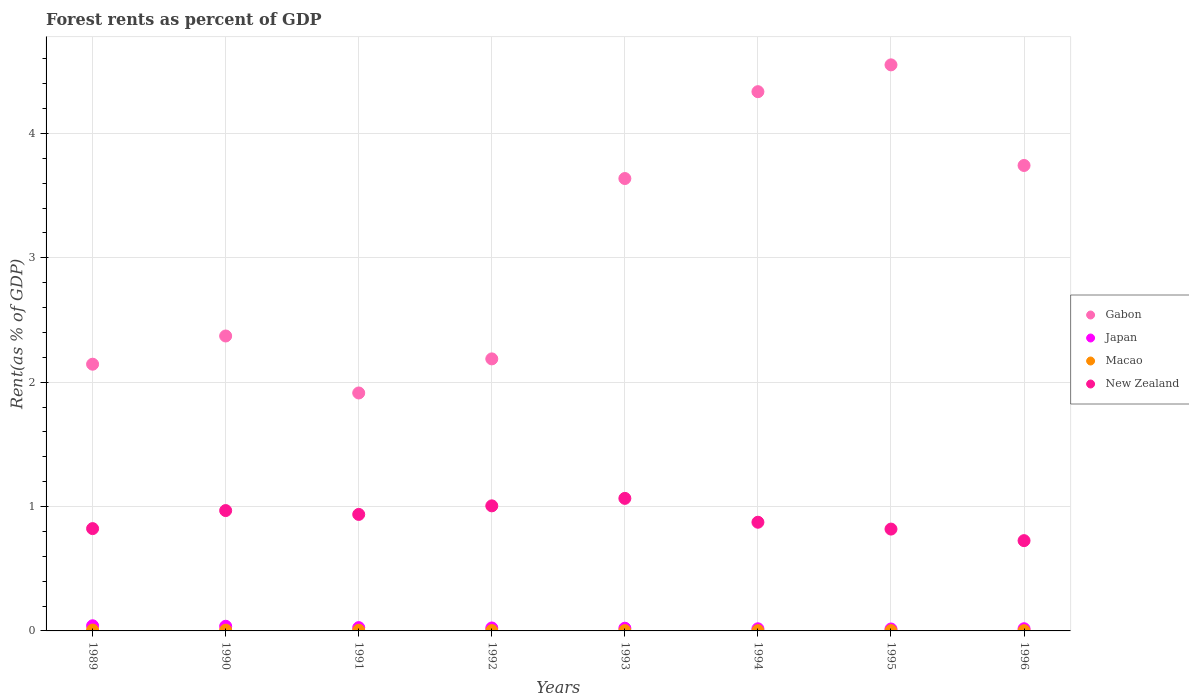What is the forest rent in Macao in 1991?
Provide a short and direct response. 0.01. Across all years, what is the maximum forest rent in Japan?
Keep it short and to the point. 0.04. Across all years, what is the minimum forest rent in Macao?
Your answer should be compact. 0. What is the total forest rent in New Zealand in the graph?
Provide a short and direct response. 7.22. What is the difference between the forest rent in Japan in 1991 and that in 1994?
Your answer should be compact. 0.01. What is the difference between the forest rent in Gabon in 1991 and the forest rent in Japan in 1992?
Provide a short and direct response. 1.89. What is the average forest rent in Macao per year?
Your answer should be compact. 0. In the year 1996, what is the difference between the forest rent in New Zealand and forest rent in Japan?
Provide a succinct answer. 0.71. What is the ratio of the forest rent in Gabon in 1991 to that in 1995?
Give a very brief answer. 0.42. What is the difference between the highest and the second highest forest rent in Japan?
Give a very brief answer. 0. What is the difference between the highest and the lowest forest rent in Japan?
Offer a terse response. 0.03. In how many years, is the forest rent in Gabon greater than the average forest rent in Gabon taken over all years?
Keep it short and to the point. 4. Is the sum of the forest rent in Gabon in 1990 and 1993 greater than the maximum forest rent in New Zealand across all years?
Make the answer very short. Yes. Is the forest rent in Gabon strictly less than the forest rent in Macao over the years?
Keep it short and to the point. No. How many dotlines are there?
Your answer should be very brief. 4. Are the values on the major ticks of Y-axis written in scientific E-notation?
Offer a terse response. No. Does the graph contain grids?
Your response must be concise. Yes. How many legend labels are there?
Provide a succinct answer. 4. What is the title of the graph?
Offer a very short reply. Forest rents as percent of GDP. What is the label or title of the Y-axis?
Give a very brief answer. Rent(as % of GDP). What is the Rent(as % of GDP) of Gabon in 1989?
Offer a very short reply. 2.14. What is the Rent(as % of GDP) of Japan in 1989?
Keep it short and to the point. 0.04. What is the Rent(as % of GDP) in Macao in 1989?
Keep it short and to the point. 0.01. What is the Rent(as % of GDP) of New Zealand in 1989?
Offer a very short reply. 0.82. What is the Rent(as % of GDP) of Gabon in 1990?
Provide a succinct answer. 2.37. What is the Rent(as % of GDP) of Japan in 1990?
Your response must be concise. 0.04. What is the Rent(as % of GDP) in Macao in 1990?
Your response must be concise. 0.01. What is the Rent(as % of GDP) in New Zealand in 1990?
Your answer should be compact. 0.97. What is the Rent(as % of GDP) in Gabon in 1991?
Your answer should be compact. 1.91. What is the Rent(as % of GDP) in Japan in 1991?
Offer a very short reply. 0.03. What is the Rent(as % of GDP) in Macao in 1991?
Your response must be concise. 0.01. What is the Rent(as % of GDP) of New Zealand in 1991?
Offer a terse response. 0.94. What is the Rent(as % of GDP) of Gabon in 1992?
Provide a succinct answer. 2.19. What is the Rent(as % of GDP) of Japan in 1992?
Your answer should be compact. 0.02. What is the Rent(as % of GDP) of Macao in 1992?
Offer a very short reply. 0. What is the Rent(as % of GDP) in New Zealand in 1992?
Your response must be concise. 1.01. What is the Rent(as % of GDP) in Gabon in 1993?
Keep it short and to the point. 3.64. What is the Rent(as % of GDP) of Japan in 1993?
Your answer should be compact. 0.02. What is the Rent(as % of GDP) in Macao in 1993?
Your response must be concise. 0. What is the Rent(as % of GDP) of New Zealand in 1993?
Provide a succinct answer. 1.07. What is the Rent(as % of GDP) of Gabon in 1994?
Keep it short and to the point. 4.34. What is the Rent(as % of GDP) in Japan in 1994?
Make the answer very short. 0.02. What is the Rent(as % of GDP) in Macao in 1994?
Ensure brevity in your answer.  0. What is the Rent(as % of GDP) of New Zealand in 1994?
Offer a very short reply. 0.87. What is the Rent(as % of GDP) of Gabon in 1995?
Provide a short and direct response. 4.55. What is the Rent(as % of GDP) in Japan in 1995?
Make the answer very short. 0.02. What is the Rent(as % of GDP) in Macao in 1995?
Give a very brief answer. 0. What is the Rent(as % of GDP) of New Zealand in 1995?
Offer a very short reply. 0.82. What is the Rent(as % of GDP) of Gabon in 1996?
Give a very brief answer. 3.74. What is the Rent(as % of GDP) of Japan in 1996?
Offer a very short reply. 0.02. What is the Rent(as % of GDP) of Macao in 1996?
Provide a short and direct response. 0. What is the Rent(as % of GDP) in New Zealand in 1996?
Offer a very short reply. 0.73. Across all years, what is the maximum Rent(as % of GDP) in Gabon?
Offer a very short reply. 4.55. Across all years, what is the maximum Rent(as % of GDP) in Japan?
Provide a succinct answer. 0.04. Across all years, what is the maximum Rent(as % of GDP) in Macao?
Your response must be concise. 0.01. Across all years, what is the maximum Rent(as % of GDP) in New Zealand?
Give a very brief answer. 1.07. Across all years, what is the minimum Rent(as % of GDP) of Gabon?
Provide a succinct answer. 1.91. Across all years, what is the minimum Rent(as % of GDP) of Japan?
Give a very brief answer. 0.02. Across all years, what is the minimum Rent(as % of GDP) in Macao?
Ensure brevity in your answer.  0. Across all years, what is the minimum Rent(as % of GDP) in New Zealand?
Make the answer very short. 0.73. What is the total Rent(as % of GDP) in Gabon in the graph?
Your answer should be compact. 24.89. What is the total Rent(as % of GDP) of Japan in the graph?
Ensure brevity in your answer.  0.2. What is the total Rent(as % of GDP) of Macao in the graph?
Give a very brief answer. 0.03. What is the total Rent(as % of GDP) in New Zealand in the graph?
Provide a succinct answer. 7.22. What is the difference between the Rent(as % of GDP) of Gabon in 1989 and that in 1990?
Your answer should be compact. -0.23. What is the difference between the Rent(as % of GDP) in Japan in 1989 and that in 1990?
Give a very brief answer. 0. What is the difference between the Rent(as % of GDP) of New Zealand in 1989 and that in 1990?
Offer a terse response. -0.15. What is the difference between the Rent(as % of GDP) of Gabon in 1989 and that in 1991?
Make the answer very short. 0.23. What is the difference between the Rent(as % of GDP) of Japan in 1989 and that in 1991?
Your answer should be compact. 0.01. What is the difference between the Rent(as % of GDP) in Macao in 1989 and that in 1991?
Give a very brief answer. 0. What is the difference between the Rent(as % of GDP) of New Zealand in 1989 and that in 1991?
Give a very brief answer. -0.11. What is the difference between the Rent(as % of GDP) of Gabon in 1989 and that in 1992?
Your response must be concise. -0.04. What is the difference between the Rent(as % of GDP) of Japan in 1989 and that in 1992?
Your response must be concise. 0.02. What is the difference between the Rent(as % of GDP) in Macao in 1989 and that in 1992?
Make the answer very short. 0. What is the difference between the Rent(as % of GDP) in New Zealand in 1989 and that in 1992?
Keep it short and to the point. -0.18. What is the difference between the Rent(as % of GDP) of Gabon in 1989 and that in 1993?
Provide a short and direct response. -1.49. What is the difference between the Rent(as % of GDP) of Japan in 1989 and that in 1993?
Offer a very short reply. 0.02. What is the difference between the Rent(as % of GDP) of Macao in 1989 and that in 1993?
Your response must be concise. 0. What is the difference between the Rent(as % of GDP) of New Zealand in 1989 and that in 1993?
Make the answer very short. -0.24. What is the difference between the Rent(as % of GDP) of Gabon in 1989 and that in 1994?
Provide a short and direct response. -2.19. What is the difference between the Rent(as % of GDP) in Japan in 1989 and that in 1994?
Your answer should be compact. 0.02. What is the difference between the Rent(as % of GDP) of Macao in 1989 and that in 1994?
Give a very brief answer. 0. What is the difference between the Rent(as % of GDP) of New Zealand in 1989 and that in 1994?
Your response must be concise. -0.05. What is the difference between the Rent(as % of GDP) of Gabon in 1989 and that in 1995?
Ensure brevity in your answer.  -2.41. What is the difference between the Rent(as % of GDP) of Japan in 1989 and that in 1995?
Give a very brief answer. 0.03. What is the difference between the Rent(as % of GDP) of Macao in 1989 and that in 1995?
Make the answer very short. 0. What is the difference between the Rent(as % of GDP) in New Zealand in 1989 and that in 1995?
Your answer should be compact. 0. What is the difference between the Rent(as % of GDP) in Gabon in 1989 and that in 1996?
Your answer should be compact. -1.6. What is the difference between the Rent(as % of GDP) in Japan in 1989 and that in 1996?
Make the answer very short. 0.02. What is the difference between the Rent(as % of GDP) in Macao in 1989 and that in 1996?
Provide a short and direct response. 0.01. What is the difference between the Rent(as % of GDP) of New Zealand in 1989 and that in 1996?
Provide a short and direct response. 0.1. What is the difference between the Rent(as % of GDP) in Gabon in 1990 and that in 1991?
Offer a very short reply. 0.46. What is the difference between the Rent(as % of GDP) of Japan in 1990 and that in 1991?
Provide a short and direct response. 0.01. What is the difference between the Rent(as % of GDP) in Macao in 1990 and that in 1991?
Your answer should be very brief. 0. What is the difference between the Rent(as % of GDP) in New Zealand in 1990 and that in 1991?
Your answer should be very brief. 0.03. What is the difference between the Rent(as % of GDP) in Gabon in 1990 and that in 1992?
Offer a terse response. 0.18. What is the difference between the Rent(as % of GDP) in Japan in 1990 and that in 1992?
Make the answer very short. 0.01. What is the difference between the Rent(as % of GDP) in Macao in 1990 and that in 1992?
Your answer should be compact. 0. What is the difference between the Rent(as % of GDP) of New Zealand in 1990 and that in 1992?
Provide a short and direct response. -0.04. What is the difference between the Rent(as % of GDP) of Gabon in 1990 and that in 1993?
Your answer should be compact. -1.27. What is the difference between the Rent(as % of GDP) in Japan in 1990 and that in 1993?
Give a very brief answer. 0.02. What is the difference between the Rent(as % of GDP) of Macao in 1990 and that in 1993?
Provide a succinct answer. 0. What is the difference between the Rent(as % of GDP) of New Zealand in 1990 and that in 1993?
Offer a very short reply. -0.1. What is the difference between the Rent(as % of GDP) of Gabon in 1990 and that in 1994?
Keep it short and to the point. -1.96. What is the difference between the Rent(as % of GDP) of Japan in 1990 and that in 1994?
Make the answer very short. 0.02. What is the difference between the Rent(as % of GDP) of Macao in 1990 and that in 1994?
Offer a very short reply. 0. What is the difference between the Rent(as % of GDP) in New Zealand in 1990 and that in 1994?
Your response must be concise. 0.09. What is the difference between the Rent(as % of GDP) in Gabon in 1990 and that in 1995?
Your response must be concise. -2.18. What is the difference between the Rent(as % of GDP) of Japan in 1990 and that in 1995?
Offer a terse response. 0.02. What is the difference between the Rent(as % of GDP) in Macao in 1990 and that in 1995?
Keep it short and to the point. 0. What is the difference between the Rent(as % of GDP) of New Zealand in 1990 and that in 1995?
Your answer should be very brief. 0.15. What is the difference between the Rent(as % of GDP) of Gabon in 1990 and that in 1996?
Give a very brief answer. -1.37. What is the difference between the Rent(as % of GDP) of Japan in 1990 and that in 1996?
Your answer should be compact. 0.02. What is the difference between the Rent(as % of GDP) in Macao in 1990 and that in 1996?
Offer a terse response. 0. What is the difference between the Rent(as % of GDP) of New Zealand in 1990 and that in 1996?
Give a very brief answer. 0.24. What is the difference between the Rent(as % of GDP) in Gabon in 1991 and that in 1992?
Make the answer very short. -0.27. What is the difference between the Rent(as % of GDP) in Japan in 1991 and that in 1992?
Your answer should be very brief. 0. What is the difference between the Rent(as % of GDP) of Macao in 1991 and that in 1992?
Offer a terse response. 0. What is the difference between the Rent(as % of GDP) of New Zealand in 1991 and that in 1992?
Your response must be concise. -0.07. What is the difference between the Rent(as % of GDP) in Gabon in 1991 and that in 1993?
Offer a very short reply. -1.72. What is the difference between the Rent(as % of GDP) of Japan in 1991 and that in 1993?
Ensure brevity in your answer.  0. What is the difference between the Rent(as % of GDP) in Macao in 1991 and that in 1993?
Make the answer very short. 0. What is the difference between the Rent(as % of GDP) of New Zealand in 1991 and that in 1993?
Ensure brevity in your answer.  -0.13. What is the difference between the Rent(as % of GDP) of Gabon in 1991 and that in 1994?
Provide a short and direct response. -2.42. What is the difference between the Rent(as % of GDP) of Japan in 1991 and that in 1994?
Ensure brevity in your answer.  0.01. What is the difference between the Rent(as % of GDP) in Macao in 1991 and that in 1994?
Your answer should be very brief. 0. What is the difference between the Rent(as % of GDP) of New Zealand in 1991 and that in 1994?
Your answer should be very brief. 0.06. What is the difference between the Rent(as % of GDP) in Gabon in 1991 and that in 1995?
Offer a terse response. -2.64. What is the difference between the Rent(as % of GDP) in Japan in 1991 and that in 1995?
Provide a short and direct response. 0.01. What is the difference between the Rent(as % of GDP) of Macao in 1991 and that in 1995?
Provide a short and direct response. 0. What is the difference between the Rent(as % of GDP) of New Zealand in 1991 and that in 1995?
Offer a terse response. 0.12. What is the difference between the Rent(as % of GDP) of Gabon in 1991 and that in 1996?
Your answer should be very brief. -1.83. What is the difference between the Rent(as % of GDP) in Japan in 1991 and that in 1996?
Keep it short and to the point. 0.01. What is the difference between the Rent(as % of GDP) in Macao in 1991 and that in 1996?
Offer a very short reply. 0. What is the difference between the Rent(as % of GDP) in New Zealand in 1991 and that in 1996?
Your answer should be very brief. 0.21. What is the difference between the Rent(as % of GDP) in Gabon in 1992 and that in 1993?
Offer a very short reply. -1.45. What is the difference between the Rent(as % of GDP) of Japan in 1992 and that in 1993?
Keep it short and to the point. 0. What is the difference between the Rent(as % of GDP) in Macao in 1992 and that in 1993?
Provide a short and direct response. 0. What is the difference between the Rent(as % of GDP) of New Zealand in 1992 and that in 1993?
Provide a short and direct response. -0.06. What is the difference between the Rent(as % of GDP) of Gabon in 1992 and that in 1994?
Offer a very short reply. -2.15. What is the difference between the Rent(as % of GDP) of Japan in 1992 and that in 1994?
Offer a terse response. 0.01. What is the difference between the Rent(as % of GDP) in Macao in 1992 and that in 1994?
Your answer should be very brief. 0. What is the difference between the Rent(as % of GDP) of New Zealand in 1992 and that in 1994?
Provide a succinct answer. 0.13. What is the difference between the Rent(as % of GDP) in Gabon in 1992 and that in 1995?
Offer a terse response. -2.36. What is the difference between the Rent(as % of GDP) in Japan in 1992 and that in 1995?
Your answer should be compact. 0.01. What is the difference between the Rent(as % of GDP) of Macao in 1992 and that in 1995?
Your response must be concise. 0. What is the difference between the Rent(as % of GDP) in New Zealand in 1992 and that in 1995?
Your answer should be compact. 0.19. What is the difference between the Rent(as % of GDP) in Gabon in 1992 and that in 1996?
Your response must be concise. -1.56. What is the difference between the Rent(as % of GDP) in Japan in 1992 and that in 1996?
Offer a terse response. 0.01. What is the difference between the Rent(as % of GDP) of New Zealand in 1992 and that in 1996?
Keep it short and to the point. 0.28. What is the difference between the Rent(as % of GDP) in Gabon in 1993 and that in 1994?
Provide a short and direct response. -0.7. What is the difference between the Rent(as % of GDP) of Japan in 1993 and that in 1994?
Provide a short and direct response. 0. What is the difference between the Rent(as % of GDP) in Macao in 1993 and that in 1994?
Offer a very short reply. -0. What is the difference between the Rent(as % of GDP) in New Zealand in 1993 and that in 1994?
Give a very brief answer. 0.19. What is the difference between the Rent(as % of GDP) in Gabon in 1993 and that in 1995?
Your answer should be compact. -0.91. What is the difference between the Rent(as % of GDP) in Japan in 1993 and that in 1995?
Make the answer very short. 0.01. What is the difference between the Rent(as % of GDP) of Macao in 1993 and that in 1995?
Give a very brief answer. -0. What is the difference between the Rent(as % of GDP) in New Zealand in 1993 and that in 1995?
Provide a succinct answer. 0.25. What is the difference between the Rent(as % of GDP) in Gabon in 1993 and that in 1996?
Your answer should be very brief. -0.1. What is the difference between the Rent(as % of GDP) in Japan in 1993 and that in 1996?
Make the answer very short. 0. What is the difference between the Rent(as % of GDP) in New Zealand in 1993 and that in 1996?
Your response must be concise. 0.34. What is the difference between the Rent(as % of GDP) in Gabon in 1994 and that in 1995?
Provide a short and direct response. -0.22. What is the difference between the Rent(as % of GDP) of Japan in 1994 and that in 1995?
Your answer should be very brief. 0. What is the difference between the Rent(as % of GDP) of Macao in 1994 and that in 1995?
Your answer should be compact. -0. What is the difference between the Rent(as % of GDP) in New Zealand in 1994 and that in 1995?
Your answer should be very brief. 0.06. What is the difference between the Rent(as % of GDP) of Gabon in 1994 and that in 1996?
Provide a short and direct response. 0.59. What is the difference between the Rent(as % of GDP) in Japan in 1994 and that in 1996?
Your answer should be very brief. -0. What is the difference between the Rent(as % of GDP) of New Zealand in 1994 and that in 1996?
Ensure brevity in your answer.  0.15. What is the difference between the Rent(as % of GDP) of Gabon in 1995 and that in 1996?
Ensure brevity in your answer.  0.81. What is the difference between the Rent(as % of GDP) of Japan in 1995 and that in 1996?
Give a very brief answer. -0. What is the difference between the Rent(as % of GDP) of Macao in 1995 and that in 1996?
Your response must be concise. 0. What is the difference between the Rent(as % of GDP) in New Zealand in 1995 and that in 1996?
Your response must be concise. 0.09. What is the difference between the Rent(as % of GDP) in Gabon in 1989 and the Rent(as % of GDP) in Japan in 1990?
Your answer should be compact. 2.11. What is the difference between the Rent(as % of GDP) in Gabon in 1989 and the Rent(as % of GDP) in Macao in 1990?
Offer a very short reply. 2.14. What is the difference between the Rent(as % of GDP) in Gabon in 1989 and the Rent(as % of GDP) in New Zealand in 1990?
Your answer should be very brief. 1.18. What is the difference between the Rent(as % of GDP) in Japan in 1989 and the Rent(as % of GDP) in Macao in 1990?
Give a very brief answer. 0.04. What is the difference between the Rent(as % of GDP) in Japan in 1989 and the Rent(as % of GDP) in New Zealand in 1990?
Provide a short and direct response. -0.93. What is the difference between the Rent(as % of GDP) in Macao in 1989 and the Rent(as % of GDP) in New Zealand in 1990?
Provide a succinct answer. -0.96. What is the difference between the Rent(as % of GDP) in Gabon in 1989 and the Rent(as % of GDP) in Japan in 1991?
Provide a short and direct response. 2.12. What is the difference between the Rent(as % of GDP) in Gabon in 1989 and the Rent(as % of GDP) in Macao in 1991?
Give a very brief answer. 2.14. What is the difference between the Rent(as % of GDP) of Gabon in 1989 and the Rent(as % of GDP) of New Zealand in 1991?
Make the answer very short. 1.21. What is the difference between the Rent(as % of GDP) of Japan in 1989 and the Rent(as % of GDP) of Macao in 1991?
Provide a short and direct response. 0.04. What is the difference between the Rent(as % of GDP) of Japan in 1989 and the Rent(as % of GDP) of New Zealand in 1991?
Keep it short and to the point. -0.9. What is the difference between the Rent(as % of GDP) of Macao in 1989 and the Rent(as % of GDP) of New Zealand in 1991?
Your answer should be compact. -0.93. What is the difference between the Rent(as % of GDP) in Gabon in 1989 and the Rent(as % of GDP) in Japan in 1992?
Your answer should be very brief. 2.12. What is the difference between the Rent(as % of GDP) in Gabon in 1989 and the Rent(as % of GDP) in Macao in 1992?
Make the answer very short. 2.14. What is the difference between the Rent(as % of GDP) of Gabon in 1989 and the Rent(as % of GDP) of New Zealand in 1992?
Offer a terse response. 1.14. What is the difference between the Rent(as % of GDP) in Japan in 1989 and the Rent(as % of GDP) in Macao in 1992?
Your answer should be compact. 0.04. What is the difference between the Rent(as % of GDP) in Japan in 1989 and the Rent(as % of GDP) in New Zealand in 1992?
Your answer should be very brief. -0.96. What is the difference between the Rent(as % of GDP) in Macao in 1989 and the Rent(as % of GDP) in New Zealand in 1992?
Keep it short and to the point. -1. What is the difference between the Rent(as % of GDP) in Gabon in 1989 and the Rent(as % of GDP) in Japan in 1993?
Your answer should be very brief. 2.12. What is the difference between the Rent(as % of GDP) in Gabon in 1989 and the Rent(as % of GDP) in Macao in 1993?
Your response must be concise. 2.14. What is the difference between the Rent(as % of GDP) of Gabon in 1989 and the Rent(as % of GDP) of New Zealand in 1993?
Make the answer very short. 1.08. What is the difference between the Rent(as % of GDP) in Japan in 1989 and the Rent(as % of GDP) in Macao in 1993?
Give a very brief answer. 0.04. What is the difference between the Rent(as % of GDP) of Japan in 1989 and the Rent(as % of GDP) of New Zealand in 1993?
Your answer should be very brief. -1.02. What is the difference between the Rent(as % of GDP) of Macao in 1989 and the Rent(as % of GDP) of New Zealand in 1993?
Offer a very short reply. -1.06. What is the difference between the Rent(as % of GDP) of Gabon in 1989 and the Rent(as % of GDP) of Japan in 1994?
Ensure brevity in your answer.  2.13. What is the difference between the Rent(as % of GDP) in Gabon in 1989 and the Rent(as % of GDP) in Macao in 1994?
Keep it short and to the point. 2.14. What is the difference between the Rent(as % of GDP) of Gabon in 1989 and the Rent(as % of GDP) of New Zealand in 1994?
Keep it short and to the point. 1.27. What is the difference between the Rent(as % of GDP) of Japan in 1989 and the Rent(as % of GDP) of Macao in 1994?
Offer a very short reply. 0.04. What is the difference between the Rent(as % of GDP) in Japan in 1989 and the Rent(as % of GDP) in New Zealand in 1994?
Ensure brevity in your answer.  -0.83. What is the difference between the Rent(as % of GDP) in Macao in 1989 and the Rent(as % of GDP) in New Zealand in 1994?
Your answer should be compact. -0.87. What is the difference between the Rent(as % of GDP) of Gabon in 1989 and the Rent(as % of GDP) of Japan in 1995?
Your answer should be very brief. 2.13. What is the difference between the Rent(as % of GDP) in Gabon in 1989 and the Rent(as % of GDP) in Macao in 1995?
Keep it short and to the point. 2.14. What is the difference between the Rent(as % of GDP) in Gabon in 1989 and the Rent(as % of GDP) in New Zealand in 1995?
Provide a succinct answer. 1.33. What is the difference between the Rent(as % of GDP) of Japan in 1989 and the Rent(as % of GDP) of Macao in 1995?
Ensure brevity in your answer.  0.04. What is the difference between the Rent(as % of GDP) of Japan in 1989 and the Rent(as % of GDP) of New Zealand in 1995?
Offer a very short reply. -0.78. What is the difference between the Rent(as % of GDP) in Macao in 1989 and the Rent(as % of GDP) in New Zealand in 1995?
Make the answer very short. -0.81. What is the difference between the Rent(as % of GDP) in Gabon in 1989 and the Rent(as % of GDP) in Japan in 1996?
Your answer should be compact. 2.13. What is the difference between the Rent(as % of GDP) in Gabon in 1989 and the Rent(as % of GDP) in Macao in 1996?
Make the answer very short. 2.14. What is the difference between the Rent(as % of GDP) of Gabon in 1989 and the Rent(as % of GDP) of New Zealand in 1996?
Offer a terse response. 1.42. What is the difference between the Rent(as % of GDP) in Japan in 1989 and the Rent(as % of GDP) in Macao in 1996?
Your answer should be compact. 0.04. What is the difference between the Rent(as % of GDP) in Japan in 1989 and the Rent(as % of GDP) in New Zealand in 1996?
Keep it short and to the point. -0.68. What is the difference between the Rent(as % of GDP) in Macao in 1989 and the Rent(as % of GDP) in New Zealand in 1996?
Ensure brevity in your answer.  -0.72. What is the difference between the Rent(as % of GDP) of Gabon in 1990 and the Rent(as % of GDP) of Japan in 1991?
Keep it short and to the point. 2.35. What is the difference between the Rent(as % of GDP) in Gabon in 1990 and the Rent(as % of GDP) in Macao in 1991?
Provide a short and direct response. 2.37. What is the difference between the Rent(as % of GDP) of Gabon in 1990 and the Rent(as % of GDP) of New Zealand in 1991?
Ensure brevity in your answer.  1.43. What is the difference between the Rent(as % of GDP) in Japan in 1990 and the Rent(as % of GDP) in Macao in 1991?
Your answer should be compact. 0.03. What is the difference between the Rent(as % of GDP) of Japan in 1990 and the Rent(as % of GDP) of New Zealand in 1991?
Give a very brief answer. -0.9. What is the difference between the Rent(as % of GDP) in Macao in 1990 and the Rent(as % of GDP) in New Zealand in 1991?
Your answer should be very brief. -0.93. What is the difference between the Rent(as % of GDP) of Gabon in 1990 and the Rent(as % of GDP) of Japan in 1992?
Offer a very short reply. 2.35. What is the difference between the Rent(as % of GDP) in Gabon in 1990 and the Rent(as % of GDP) in Macao in 1992?
Keep it short and to the point. 2.37. What is the difference between the Rent(as % of GDP) of Gabon in 1990 and the Rent(as % of GDP) of New Zealand in 1992?
Offer a very short reply. 1.37. What is the difference between the Rent(as % of GDP) in Japan in 1990 and the Rent(as % of GDP) in Macao in 1992?
Offer a terse response. 0.03. What is the difference between the Rent(as % of GDP) of Japan in 1990 and the Rent(as % of GDP) of New Zealand in 1992?
Provide a short and direct response. -0.97. What is the difference between the Rent(as % of GDP) in Macao in 1990 and the Rent(as % of GDP) in New Zealand in 1992?
Provide a short and direct response. -1. What is the difference between the Rent(as % of GDP) of Gabon in 1990 and the Rent(as % of GDP) of Japan in 1993?
Provide a short and direct response. 2.35. What is the difference between the Rent(as % of GDP) of Gabon in 1990 and the Rent(as % of GDP) of Macao in 1993?
Your answer should be compact. 2.37. What is the difference between the Rent(as % of GDP) in Gabon in 1990 and the Rent(as % of GDP) in New Zealand in 1993?
Give a very brief answer. 1.31. What is the difference between the Rent(as % of GDP) of Japan in 1990 and the Rent(as % of GDP) of Macao in 1993?
Offer a very short reply. 0.04. What is the difference between the Rent(as % of GDP) in Japan in 1990 and the Rent(as % of GDP) in New Zealand in 1993?
Your response must be concise. -1.03. What is the difference between the Rent(as % of GDP) in Macao in 1990 and the Rent(as % of GDP) in New Zealand in 1993?
Offer a very short reply. -1.06. What is the difference between the Rent(as % of GDP) in Gabon in 1990 and the Rent(as % of GDP) in Japan in 1994?
Give a very brief answer. 2.35. What is the difference between the Rent(as % of GDP) in Gabon in 1990 and the Rent(as % of GDP) in Macao in 1994?
Provide a short and direct response. 2.37. What is the difference between the Rent(as % of GDP) of Gabon in 1990 and the Rent(as % of GDP) of New Zealand in 1994?
Make the answer very short. 1.5. What is the difference between the Rent(as % of GDP) in Japan in 1990 and the Rent(as % of GDP) in Macao in 1994?
Your answer should be very brief. 0.04. What is the difference between the Rent(as % of GDP) in Japan in 1990 and the Rent(as % of GDP) in New Zealand in 1994?
Offer a terse response. -0.84. What is the difference between the Rent(as % of GDP) in Macao in 1990 and the Rent(as % of GDP) in New Zealand in 1994?
Keep it short and to the point. -0.87. What is the difference between the Rent(as % of GDP) of Gabon in 1990 and the Rent(as % of GDP) of Japan in 1995?
Provide a short and direct response. 2.36. What is the difference between the Rent(as % of GDP) in Gabon in 1990 and the Rent(as % of GDP) in Macao in 1995?
Ensure brevity in your answer.  2.37. What is the difference between the Rent(as % of GDP) in Gabon in 1990 and the Rent(as % of GDP) in New Zealand in 1995?
Your response must be concise. 1.55. What is the difference between the Rent(as % of GDP) in Japan in 1990 and the Rent(as % of GDP) in Macao in 1995?
Make the answer very short. 0.04. What is the difference between the Rent(as % of GDP) of Japan in 1990 and the Rent(as % of GDP) of New Zealand in 1995?
Keep it short and to the point. -0.78. What is the difference between the Rent(as % of GDP) in Macao in 1990 and the Rent(as % of GDP) in New Zealand in 1995?
Offer a terse response. -0.81. What is the difference between the Rent(as % of GDP) in Gabon in 1990 and the Rent(as % of GDP) in Japan in 1996?
Your answer should be compact. 2.35. What is the difference between the Rent(as % of GDP) in Gabon in 1990 and the Rent(as % of GDP) in Macao in 1996?
Offer a terse response. 2.37. What is the difference between the Rent(as % of GDP) in Gabon in 1990 and the Rent(as % of GDP) in New Zealand in 1996?
Offer a very short reply. 1.65. What is the difference between the Rent(as % of GDP) of Japan in 1990 and the Rent(as % of GDP) of Macao in 1996?
Your answer should be very brief. 0.04. What is the difference between the Rent(as % of GDP) of Japan in 1990 and the Rent(as % of GDP) of New Zealand in 1996?
Offer a terse response. -0.69. What is the difference between the Rent(as % of GDP) of Macao in 1990 and the Rent(as % of GDP) of New Zealand in 1996?
Provide a short and direct response. -0.72. What is the difference between the Rent(as % of GDP) in Gabon in 1991 and the Rent(as % of GDP) in Japan in 1992?
Make the answer very short. 1.89. What is the difference between the Rent(as % of GDP) in Gabon in 1991 and the Rent(as % of GDP) in Macao in 1992?
Keep it short and to the point. 1.91. What is the difference between the Rent(as % of GDP) in Gabon in 1991 and the Rent(as % of GDP) in New Zealand in 1992?
Ensure brevity in your answer.  0.91. What is the difference between the Rent(as % of GDP) in Japan in 1991 and the Rent(as % of GDP) in Macao in 1992?
Offer a very short reply. 0.02. What is the difference between the Rent(as % of GDP) in Japan in 1991 and the Rent(as % of GDP) in New Zealand in 1992?
Your response must be concise. -0.98. What is the difference between the Rent(as % of GDP) in Macao in 1991 and the Rent(as % of GDP) in New Zealand in 1992?
Your response must be concise. -1. What is the difference between the Rent(as % of GDP) in Gabon in 1991 and the Rent(as % of GDP) in Japan in 1993?
Provide a short and direct response. 1.89. What is the difference between the Rent(as % of GDP) in Gabon in 1991 and the Rent(as % of GDP) in Macao in 1993?
Make the answer very short. 1.91. What is the difference between the Rent(as % of GDP) of Gabon in 1991 and the Rent(as % of GDP) of New Zealand in 1993?
Offer a very short reply. 0.85. What is the difference between the Rent(as % of GDP) in Japan in 1991 and the Rent(as % of GDP) in Macao in 1993?
Your response must be concise. 0.02. What is the difference between the Rent(as % of GDP) of Japan in 1991 and the Rent(as % of GDP) of New Zealand in 1993?
Ensure brevity in your answer.  -1.04. What is the difference between the Rent(as % of GDP) of Macao in 1991 and the Rent(as % of GDP) of New Zealand in 1993?
Offer a very short reply. -1.06. What is the difference between the Rent(as % of GDP) in Gabon in 1991 and the Rent(as % of GDP) in Japan in 1994?
Your answer should be very brief. 1.9. What is the difference between the Rent(as % of GDP) of Gabon in 1991 and the Rent(as % of GDP) of Macao in 1994?
Your answer should be compact. 1.91. What is the difference between the Rent(as % of GDP) in Gabon in 1991 and the Rent(as % of GDP) in New Zealand in 1994?
Provide a succinct answer. 1.04. What is the difference between the Rent(as % of GDP) of Japan in 1991 and the Rent(as % of GDP) of Macao in 1994?
Your answer should be compact. 0.02. What is the difference between the Rent(as % of GDP) in Japan in 1991 and the Rent(as % of GDP) in New Zealand in 1994?
Offer a terse response. -0.85. What is the difference between the Rent(as % of GDP) in Macao in 1991 and the Rent(as % of GDP) in New Zealand in 1994?
Ensure brevity in your answer.  -0.87. What is the difference between the Rent(as % of GDP) of Gabon in 1991 and the Rent(as % of GDP) of Japan in 1995?
Make the answer very short. 1.9. What is the difference between the Rent(as % of GDP) in Gabon in 1991 and the Rent(as % of GDP) in Macao in 1995?
Provide a succinct answer. 1.91. What is the difference between the Rent(as % of GDP) in Gabon in 1991 and the Rent(as % of GDP) in New Zealand in 1995?
Make the answer very short. 1.09. What is the difference between the Rent(as % of GDP) of Japan in 1991 and the Rent(as % of GDP) of Macao in 1995?
Keep it short and to the point. 0.02. What is the difference between the Rent(as % of GDP) of Japan in 1991 and the Rent(as % of GDP) of New Zealand in 1995?
Provide a short and direct response. -0.79. What is the difference between the Rent(as % of GDP) of Macao in 1991 and the Rent(as % of GDP) of New Zealand in 1995?
Make the answer very short. -0.81. What is the difference between the Rent(as % of GDP) of Gabon in 1991 and the Rent(as % of GDP) of Japan in 1996?
Provide a short and direct response. 1.9. What is the difference between the Rent(as % of GDP) of Gabon in 1991 and the Rent(as % of GDP) of Macao in 1996?
Your response must be concise. 1.91. What is the difference between the Rent(as % of GDP) of Gabon in 1991 and the Rent(as % of GDP) of New Zealand in 1996?
Your response must be concise. 1.19. What is the difference between the Rent(as % of GDP) in Japan in 1991 and the Rent(as % of GDP) in Macao in 1996?
Your answer should be compact. 0.02. What is the difference between the Rent(as % of GDP) in Japan in 1991 and the Rent(as % of GDP) in New Zealand in 1996?
Make the answer very short. -0.7. What is the difference between the Rent(as % of GDP) of Macao in 1991 and the Rent(as % of GDP) of New Zealand in 1996?
Your answer should be compact. -0.72. What is the difference between the Rent(as % of GDP) of Gabon in 1992 and the Rent(as % of GDP) of Japan in 1993?
Your response must be concise. 2.17. What is the difference between the Rent(as % of GDP) in Gabon in 1992 and the Rent(as % of GDP) in Macao in 1993?
Provide a short and direct response. 2.19. What is the difference between the Rent(as % of GDP) in Gabon in 1992 and the Rent(as % of GDP) in New Zealand in 1993?
Keep it short and to the point. 1.12. What is the difference between the Rent(as % of GDP) in Japan in 1992 and the Rent(as % of GDP) in Macao in 1993?
Your response must be concise. 0.02. What is the difference between the Rent(as % of GDP) of Japan in 1992 and the Rent(as % of GDP) of New Zealand in 1993?
Keep it short and to the point. -1.04. What is the difference between the Rent(as % of GDP) of Macao in 1992 and the Rent(as % of GDP) of New Zealand in 1993?
Keep it short and to the point. -1.06. What is the difference between the Rent(as % of GDP) in Gabon in 1992 and the Rent(as % of GDP) in Japan in 1994?
Give a very brief answer. 2.17. What is the difference between the Rent(as % of GDP) in Gabon in 1992 and the Rent(as % of GDP) in Macao in 1994?
Ensure brevity in your answer.  2.19. What is the difference between the Rent(as % of GDP) of Gabon in 1992 and the Rent(as % of GDP) of New Zealand in 1994?
Offer a terse response. 1.31. What is the difference between the Rent(as % of GDP) in Japan in 1992 and the Rent(as % of GDP) in Macao in 1994?
Your answer should be compact. 0.02. What is the difference between the Rent(as % of GDP) in Japan in 1992 and the Rent(as % of GDP) in New Zealand in 1994?
Keep it short and to the point. -0.85. What is the difference between the Rent(as % of GDP) of Macao in 1992 and the Rent(as % of GDP) of New Zealand in 1994?
Ensure brevity in your answer.  -0.87. What is the difference between the Rent(as % of GDP) in Gabon in 1992 and the Rent(as % of GDP) in Japan in 1995?
Keep it short and to the point. 2.17. What is the difference between the Rent(as % of GDP) in Gabon in 1992 and the Rent(as % of GDP) in Macao in 1995?
Your response must be concise. 2.19. What is the difference between the Rent(as % of GDP) of Gabon in 1992 and the Rent(as % of GDP) of New Zealand in 1995?
Ensure brevity in your answer.  1.37. What is the difference between the Rent(as % of GDP) of Japan in 1992 and the Rent(as % of GDP) of Macao in 1995?
Ensure brevity in your answer.  0.02. What is the difference between the Rent(as % of GDP) in Japan in 1992 and the Rent(as % of GDP) in New Zealand in 1995?
Offer a very short reply. -0.8. What is the difference between the Rent(as % of GDP) in Macao in 1992 and the Rent(as % of GDP) in New Zealand in 1995?
Your answer should be very brief. -0.82. What is the difference between the Rent(as % of GDP) of Gabon in 1992 and the Rent(as % of GDP) of Japan in 1996?
Your answer should be very brief. 2.17. What is the difference between the Rent(as % of GDP) of Gabon in 1992 and the Rent(as % of GDP) of Macao in 1996?
Make the answer very short. 2.19. What is the difference between the Rent(as % of GDP) in Gabon in 1992 and the Rent(as % of GDP) in New Zealand in 1996?
Give a very brief answer. 1.46. What is the difference between the Rent(as % of GDP) in Japan in 1992 and the Rent(as % of GDP) in Macao in 1996?
Give a very brief answer. 0.02. What is the difference between the Rent(as % of GDP) in Japan in 1992 and the Rent(as % of GDP) in New Zealand in 1996?
Provide a succinct answer. -0.7. What is the difference between the Rent(as % of GDP) of Macao in 1992 and the Rent(as % of GDP) of New Zealand in 1996?
Your answer should be compact. -0.72. What is the difference between the Rent(as % of GDP) of Gabon in 1993 and the Rent(as % of GDP) of Japan in 1994?
Your answer should be compact. 3.62. What is the difference between the Rent(as % of GDP) of Gabon in 1993 and the Rent(as % of GDP) of Macao in 1994?
Make the answer very short. 3.64. What is the difference between the Rent(as % of GDP) of Gabon in 1993 and the Rent(as % of GDP) of New Zealand in 1994?
Give a very brief answer. 2.76. What is the difference between the Rent(as % of GDP) of Japan in 1993 and the Rent(as % of GDP) of Macao in 1994?
Your response must be concise. 0.02. What is the difference between the Rent(as % of GDP) in Japan in 1993 and the Rent(as % of GDP) in New Zealand in 1994?
Make the answer very short. -0.85. What is the difference between the Rent(as % of GDP) of Macao in 1993 and the Rent(as % of GDP) of New Zealand in 1994?
Your answer should be compact. -0.87. What is the difference between the Rent(as % of GDP) in Gabon in 1993 and the Rent(as % of GDP) in Japan in 1995?
Your answer should be compact. 3.62. What is the difference between the Rent(as % of GDP) in Gabon in 1993 and the Rent(as % of GDP) in Macao in 1995?
Keep it short and to the point. 3.64. What is the difference between the Rent(as % of GDP) of Gabon in 1993 and the Rent(as % of GDP) of New Zealand in 1995?
Give a very brief answer. 2.82. What is the difference between the Rent(as % of GDP) in Japan in 1993 and the Rent(as % of GDP) in Macao in 1995?
Ensure brevity in your answer.  0.02. What is the difference between the Rent(as % of GDP) of Japan in 1993 and the Rent(as % of GDP) of New Zealand in 1995?
Your answer should be very brief. -0.8. What is the difference between the Rent(as % of GDP) in Macao in 1993 and the Rent(as % of GDP) in New Zealand in 1995?
Give a very brief answer. -0.82. What is the difference between the Rent(as % of GDP) in Gabon in 1993 and the Rent(as % of GDP) in Japan in 1996?
Give a very brief answer. 3.62. What is the difference between the Rent(as % of GDP) of Gabon in 1993 and the Rent(as % of GDP) of Macao in 1996?
Give a very brief answer. 3.64. What is the difference between the Rent(as % of GDP) of Gabon in 1993 and the Rent(as % of GDP) of New Zealand in 1996?
Provide a succinct answer. 2.91. What is the difference between the Rent(as % of GDP) of Japan in 1993 and the Rent(as % of GDP) of Macao in 1996?
Make the answer very short. 0.02. What is the difference between the Rent(as % of GDP) of Japan in 1993 and the Rent(as % of GDP) of New Zealand in 1996?
Provide a short and direct response. -0.7. What is the difference between the Rent(as % of GDP) in Macao in 1993 and the Rent(as % of GDP) in New Zealand in 1996?
Offer a very short reply. -0.72. What is the difference between the Rent(as % of GDP) in Gabon in 1994 and the Rent(as % of GDP) in Japan in 1995?
Make the answer very short. 4.32. What is the difference between the Rent(as % of GDP) in Gabon in 1994 and the Rent(as % of GDP) in Macao in 1995?
Your answer should be compact. 4.33. What is the difference between the Rent(as % of GDP) of Gabon in 1994 and the Rent(as % of GDP) of New Zealand in 1995?
Your answer should be very brief. 3.52. What is the difference between the Rent(as % of GDP) of Japan in 1994 and the Rent(as % of GDP) of Macao in 1995?
Your answer should be compact. 0.01. What is the difference between the Rent(as % of GDP) in Japan in 1994 and the Rent(as % of GDP) in New Zealand in 1995?
Offer a very short reply. -0.8. What is the difference between the Rent(as % of GDP) in Macao in 1994 and the Rent(as % of GDP) in New Zealand in 1995?
Ensure brevity in your answer.  -0.82. What is the difference between the Rent(as % of GDP) in Gabon in 1994 and the Rent(as % of GDP) in Japan in 1996?
Provide a succinct answer. 4.32. What is the difference between the Rent(as % of GDP) in Gabon in 1994 and the Rent(as % of GDP) in Macao in 1996?
Make the answer very short. 4.33. What is the difference between the Rent(as % of GDP) in Gabon in 1994 and the Rent(as % of GDP) in New Zealand in 1996?
Make the answer very short. 3.61. What is the difference between the Rent(as % of GDP) in Japan in 1994 and the Rent(as % of GDP) in Macao in 1996?
Make the answer very short. 0.02. What is the difference between the Rent(as % of GDP) of Japan in 1994 and the Rent(as % of GDP) of New Zealand in 1996?
Your answer should be compact. -0.71. What is the difference between the Rent(as % of GDP) of Macao in 1994 and the Rent(as % of GDP) of New Zealand in 1996?
Your response must be concise. -0.72. What is the difference between the Rent(as % of GDP) of Gabon in 1995 and the Rent(as % of GDP) of Japan in 1996?
Your answer should be compact. 4.53. What is the difference between the Rent(as % of GDP) of Gabon in 1995 and the Rent(as % of GDP) of Macao in 1996?
Your answer should be very brief. 4.55. What is the difference between the Rent(as % of GDP) of Gabon in 1995 and the Rent(as % of GDP) of New Zealand in 1996?
Your answer should be compact. 3.83. What is the difference between the Rent(as % of GDP) of Japan in 1995 and the Rent(as % of GDP) of Macao in 1996?
Your response must be concise. 0.01. What is the difference between the Rent(as % of GDP) of Japan in 1995 and the Rent(as % of GDP) of New Zealand in 1996?
Give a very brief answer. -0.71. What is the difference between the Rent(as % of GDP) of Macao in 1995 and the Rent(as % of GDP) of New Zealand in 1996?
Keep it short and to the point. -0.72. What is the average Rent(as % of GDP) in Gabon per year?
Make the answer very short. 3.11. What is the average Rent(as % of GDP) in Japan per year?
Your response must be concise. 0.03. What is the average Rent(as % of GDP) in Macao per year?
Provide a succinct answer. 0. What is the average Rent(as % of GDP) in New Zealand per year?
Your response must be concise. 0.9. In the year 1989, what is the difference between the Rent(as % of GDP) in Gabon and Rent(as % of GDP) in Japan?
Ensure brevity in your answer.  2.1. In the year 1989, what is the difference between the Rent(as % of GDP) of Gabon and Rent(as % of GDP) of Macao?
Give a very brief answer. 2.14. In the year 1989, what is the difference between the Rent(as % of GDP) in Gabon and Rent(as % of GDP) in New Zealand?
Your answer should be compact. 1.32. In the year 1989, what is the difference between the Rent(as % of GDP) of Japan and Rent(as % of GDP) of Macao?
Provide a short and direct response. 0.03. In the year 1989, what is the difference between the Rent(as % of GDP) of Japan and Rent(as % of GDP) of New Zealand?
Keep it short and to the point. -0.78. In the year 1989, what is the difference between the Rent(as % of GDP) in Macao and Rent(as % of GDP) in New Zealand?
Provide a short and direct response. -0.82. In the year 1990, what is the difference between the Rent(as % of GDP) of Gabon and Rent(as % of GDP) of Japan?
Keep it short and to the point. 2.33. In the year 1990, what is the difference between the Rent(as % of GDP) in Gabon and Rent(as % of GDP) in Macao?
Keep it short and to the point. 2.37. In the year 1990, what is the difference between the Rent(as % of GDP) in Gabon and Rent(as % of GDP) in New Zealand?
Provide a short and direct response. 1.4. In the year 1990, what is the difference between the Rent(as % of GDP) in Japan and Rent(as % of GDP) in Macao?
Your answer should be very brief. 0.03. In the year 1990, what is the difference between the Rent(as % of GDP) in Japan and Rent(as % of GDP) in New Zealand?
Provide a short and direct response. -0.93. In the year 1990, what is the difference between the Rent(as % of GDP) in Macao and Rent(as % of GDP) in New Zealand?
Provide a short and direct response. -0.96. In the year 1991, what is the difference between the Rent(as % of GDP) in Gabon and Rent(as % of GDP) in Japan?
Offer a terse response. 1.89. In the year 1991, what is the difference between the Rent(as % of GDP) in Gabon and Rent(as % of GDP) in Macao?
Offer a very short reply. 1.91. In the year 1991, what is the difference between the Rent(as % of GDP) in Gabon and Rent(as % of GDP) in New Zealand?
Your answer should be very brief. 0.98. In the year 1991, what is the difference between the Rent(as % of GDP) of Japan and Rent(as % of GDP) of Macao?
Provide a succinct answer. 0.02. In the year 1991, what is the difference between the Rent(as % of GDP) of Japan and Rent(as % of GDP) of New Zealand?
Provide a succinct answer. -0.91. In the year 1991, what is the difference between the Rent(as % of GDP) of Macao and Rent(as % of GDP) of New Zealand?
Give a very brief answer. -0.93. In the year 1992, what is the difference between the Rent(as % of GDP) in Gabon and Rent(as % of GDP) in Japan?
Your response must be concise. 2.16. In the year 1992, what is the difference between the Rent(as % of GDP) of Gabon and Rent(as % of GDP) of Macao?
Ensure brevity in your answer.  2.18. In the year 1992, what is the difference between the Rent(as % of GDP) in Gabon and Rent(as % of GDP) in New Zealand?
Your response must be concise. 1.18. In the year 1992, what is the difference between the Rent(as % of GDP) in Japan and Rent(as % of GDP) in Macao?
Keep it short and to the point. 0.02. In the year 1992, what is the difference between the Rent(as % of GDP) of Japan and Rent(as % of GDP) of New Zealand?
Provide a short and direct response. -0.98. In the year 1992, what is the difference between the Rent(as % of GDP) in Macao and Rent(as % of GDP) in New Zealand?
Give a very brief answer. -1. In the year 1993, what is the difference between the Rent(as % of GDP) in Gabon and Rent(as % of GDP) in Japan?
Your response must be concise. 3.62. In the year 1993, what is the difference between the Rent(as % of GDP) in Gabon and Rent(as % of GDP) in Macao?
Make the answer very short. 3.64. In the year 1993, what is the difference between the Rent(as % of GDP) in Gabon and Rent(as % of GDP) in New Zealand?
Give a very brief answer. 2.57. In the year 1993, what is the difference between the Rent(as % of GDP) of Japan and Rent(as % of GDP) of Macao?
Ensure brevity in your answer.  0.02. In the year 1993, what is the difference between the Rent(as % of GDP) in Japan and Rent(as % of GDP) in New Zealand?
Make the answer very short. -1.04. In the year 1993, what is the difference between the Rent(as % of GDP) in Macao and Rent(as % of GDP) in New Zealand?
Your response must be concise. -1.06. In the year 1994, what is the difference between the Rent(as % of GDP) in Gabon and Rent(as % of GDP) in Japan?
Offer a very short reply. 4.32. In the year 1994, what is the difference between the Rent(as % of GDP) of Gabon and Rent(as % of GDP) of Macao?
Your answer should be very brief. 4.33. In the year 1994, what is the difference between the Rent(as % of GDP) in Gabon and Rent(as % of GDP) in New Zealand?
Offer a very short reply. 3.46. In the year 1994, what is the difference between the Rent(as % of GDP) of Japan and Rent(as % of GDP) of Macao?
Ensure brevity in your answer.  0.01. In the year 1994, what is the difference between the Rent(as % of GDP) of Japan and Rent(as % of GDP) of New Zealand?
Your answer should be compact. -0.86. In the year 1994, what is the difference between the Rent(as % of GDP) of Macao and Rent(as % of GDP) of New Zealand?
Give a very brief answer. -0.87. In the year 1995, what is the difference between the Rent(as % of GDP) of Gabon and Rent(as % of GDP) of Japan?
Your answer should be very brief. 4.54. In the year 1995, what is the difference between the Rent(as % of GDP) of Gabon and Rent(as % of GDP) of Macao?
Keep it short and to the point. 4.55. In the year 1995, what is the difference between the Rent(as % of GDP) of Gabon and Rent(as % of GDP) of New Zealand?
Make the answer very short. 3.73. In the year 1995, what is the difference between the Rent(as % of GDP) in Japan and Rent(as % of GDP) in Macao?
Your response must be concise. 0.01. In the year 1995, what is the difference between the Rent(as % of GDP) in Japan and Rent(as % of GDP) in New Zealand?
Offer a terse response. -0.8. In the year 1995, what is the difference between the Rent(as % of GDP) in Macao and Rent(as % of GDP) in New Zealand?
Provide a succinct answer. -0.82. In the year 1996, what is the difference between the Rent(as % of GDP) in Gabon and Rent(as % of GDP) in Japan?
Provide a succinct answer. 3.73. In the year 1996, what is the difference between the Rent(as % of GDP) in Gabon and Rent(as % of GDP) in Macao?
Your answer should be very brief. 3.74. In the year 1996, what is the difference between the Rent(as % of GDP) of Gabon and Rent(as % of GDP) of New Zealand?
Your answer should be compact. 3.02. In the year 1996, what is the difference between the Rent(as % of GDP) of Japan and Rent(as % of GDP) of Macao?
Your answer should be very brief. 0.02. In the year 1996, what is the difference between the Rent(as % of GDP) of Japan and Rent(as % of GDP) of New Zealand?
Keep it short and to the point. -0.71. In the year 1996, what is the difference between the Rent(as % of GDP) in Macao and Rent(as % of GDP) in New Zealand?
Make the answer very short. -0.72. What is the ratio of the Rent(as % of GDP) of Gabon in 1989 to that in 1990?
Keep it short and to the point. 0.9. What is the ratio of the Rent(as % of GDP) in Japan in 1989 to that in 1990?
Your answer should be very brief. 1.1. What is the ratio of the Rent(as % of GDP) of Macao in 1989 to that in 1990?
Ensure brevity in your answer.  1.17. What is the ratio of the Rent(as % of GDP) in New Zealand in 1989 to that in 1990?
Ensure brevity in your answer.  0.85. What is the ratio of the Rent(as % of GDP) of Gabon in 1989 to that in 1991?
Your response must be concise. 1.12. What is the ratio of the Rent(as % of GDP) in Japan in 1989 to that in 1991?
Keep it short and to the point. 1.56. What is the ratio of the Rent(as % of GDP) of Macao in 1989 to that in 1991?
Your answer should be very brief. 1.31. What is the ratio of the Rent(as % of GDP) of New Zealand in 1989 to that in 1991?
Your answer should be very brief. 0.88. What is the ratio of the Rent(as % of GDP) in Gabon in 1989 to that in 1992?
Provide a short and direct response. 0.98. What is the ratio of the Rent(as % of GDP) of Japan in 1989 to that in 1992?
Your answer should be compact. 1.75. What is the ratio of the Rent(as % of GDP) of Macao in 1989 to that in 1992?
Your answer should be very brief. 2.4. What is the ratio of the Rent(as % of GDP) in New Zealand in 1989 to that in 1992?
Your answer should be compact. 0.82. What is the ratio of the Rent(as % of GDP) of Gabon in 1989 to that in 1993?
Keep it short and to the point. 0.59. What is the ratio of the Rent(as % of GDP) of Japan in 1989 to that in 1993?
Your answer should be very brief. 1.9. What is the ratio of the Rent(as % of GDP) of Macao in 1989 to that in 1993?
Your answer should be compact. 3.32. What is the ratio of the Rent(as % of GDP) in New Zealand in 1989 to that in 1993?
Your answer should be very brief. 0.77. What is the ratio of the Rent(as % of GDP) of Gabon in 1989 to that in 1994?
Keep it short and to the point. 0.49. What is the ratio of the Rent(as % of GDP) of Japan in 1989 to that in 1994?
Your response must be concise. 2.41. What is the ratio of the Rent(as % of GDP) in Macao in 1989 to that in 1994?
Give a very brief answer. 3.31. What is the ratio of the Rent(as % of GDP) in New Zealand in 1989 to that in 1994?
Offer a very short reply. 0.94. What is the ratio of the Rent(as % of GDP) in Gabon in 1989 to that in 1995?
Your response must be concise. 0.47. What is the ratio of the Rent(as % of GDP) in Japan in 1989 to that in 1995?
Ensure brevity in your answer.  2.67. What is the ratio of the Rent(as % of GDP) in Macao in 1989 to that in 1995?
Give a very brief answer. 3.01. What is the ratio of the Rent(as % of GDP) in Gabon in 1989 to that in 1996?
Offer a terse response. 0.57. What is the ratio of the Rent(as % of GDP) of Japan in 1989 to that in 1996?
Your response must be concise. 2.36. What is the ratio of the Rent(as % of GDP) of Macao in 1989 to that in 1996?
Your answer should be very brief. 3.71. What is the ratio of the Rent(as % of GDP) of New Zealand in 1989 to that in 1996?
Your answer should be very brief. 1.13. What is the ratio of the Rent(as % of GDP) in Gabon in 1990 to that in 1991?
Keep it short and to the point. 1.24. What is the ratio of the Rent(as % of GDP) of Japan in 1990 to that in 1991?
Offer a very short reply. 1.41. What is the ratio of the Rent(as % of GDP) of Macao in 1990 to that in 1991?
Make the answer very short. 1.12. What is the ratio of the Rent(as % of GDP) in New Zealand in 1990 to that in 1991?
Ensure brevity in your answer.  1.03. What is the ratio of the Rent(as % of GDP) of Gabon in 1990 to that in 1992?
Keep it short and to the point. 1.08. What is the ratio of the Rent(as % of GDP) in Japan in 1990 to that in 1992?
Offer a terse response. 1.58. What is the ratio of the Rent(as % of GDP) in Macao in 1990 to that in 1992?
Make the answer very short. 2.06. What is the ratio of the Rent(as % of GDP) of New Zealand in 1990 to that in 1992?
Ensure brevity in your answer.  0.96. What is the ratio of the Rent(as % of GDP) in Gabon in 1990 to that in 1993?
Offer a terse response. 0.65. What is the ratio of the Rent(as % of GDP) of Japan in 1990 to that in 1993?
Your response must be concise. 1.72. What is the ratio of the Rent(as % of GDP) of Macao in 1990 to that in 1993?
Your answer should be compact. 2.85. What is the ratio of the Rent(as % of GDP) in New Zealand in 1990 to that in 1993?
Give a very brief answer. 0.91. What is the ratio of the Rent(as % of GDP) of Gabon in 1990 to that in 1994?
Your answer should be very brief. 0.55. What is the ratio of the Rent(as % of GDP) of Japan in 1990 to that in 1994?
Ensure brevity in your answer.  2.18. What is the ratio of the Rent(as % of GDP) in Macao in 1990 to that in 1994?
Your answer should be compact. 2.84. What is the ratio of the Rent(as % of GDP) of New Zealand in 1990 to that in 1994?
Provide a succinct answer. 1.11. What is the ratio of the Rent(as % of GDP) of Gabon in 1990 to that in 1995?
Offer a terse response. 0.52. What is the ratio of the Rent(as % of GDP) in Japan in 1990 to that in 1995?
Offer a very short reply. 2.42. What is the ratio of the Rent(as % of GDP) of Macao in 1990 to that in 1995?
Provide a succinct answer. 2.58. What is the ratio of the Rent(as % of GDP) of New Zealand in 1990 to that in 1995?
Keep it short and to the point. 1.18. What is the ratio of the Rent(as % of GDP) in Gabon in 1990 to that in 1996?
Your response must be concise. 0.63. What is the ratio of the Rent(as % of GDP) of Japan in 1990 to that in 1996?
Give a very brief answer. 2.13. What is the ratio of the Rent(as % of GDP) of Macao in 1990 to that in 1996?
Your answer should be compact. 3.18. What is the ratio of the Rent(as % of GDP) in New Zealand in 1990 to that in 1996?
Provide a succinct answer. 1.33. What is the ratio of the Rent(as % of GDP) of Gabon in 1991 to that in 1992?
Keep it short and to the point. 0.87. What is the ratio of the Rent(as % of GDP) in Japan in 1991 to that in 1992?
Offer a terse response. 1.12. What is the ratio of the Rent(as % of GDP) of Macao in 1991 to that in 1992?
Offer a very short reply. 1.83. What is the ratio of the Rent(as % of GDP) in New Zealand in 1991 to that in 1992?
Your response must be concise. 0.93. What is the ratio of the Rent(as % of GDP) in Gabon in 1991 to that in 1993?
Ensure brevity in your answer.  0.53. What is the ratio of the Rent(as % of GDP) in Japan in 1991 to that in 1993?
Offer a terse response. 1.22. What is the ratio of the Rent(as % of GDP) of Macao in 1991 to that in 1993?
Provide a succinct answer. 2.53. What is the ratio of the Rent(as % of GDP) in New Zealand in 1991 to that in 1993?
Make the answer very short. 0.88. What is the ratio of the Rent(as % of GDP) in Gabon in 1991 to that in 1994?
Keep it short and to the point. 0.44. What is the ratio of the Rent(as % of GDP) of Japan in 1991 to that in 1994?
Give a very brief answer. 1.55. What is the ratio of the Rent(as % of GDP) in Macao in 1991 to that in 1994?
Provide a succinct answer. 2.53. What is the ratio of the Rent(as % of GDP) of New Zealand in 1991 to that in 1994?
Your answer should be compact. 1.07. What is the ratio of the Rent(as % of GDP) in Gabon in 1991 to that in 1995?
Provide a short and direct response. 0.42. What is the ratio of the Rent(as % of GDP) of Japan in 1991 to that in 1995?
Make the answer very short. 1.71. What is the ratio of the Rent(as % of GDP) of Macao in 1991 to that in 1995?
Make the answer very short. 2.3. What is the ratio of the Rent(as % of GDP) in New Zealand in 1991 to that in 1995?
Provide a short and direct response. 1.14. What is the ratio of the Rent(as % of GDP) of Gabon in 1991 to that in 1996?
Give a very brief answer. 0.51. What is the ratio of the Rent(as % of GDP) in Japan in 1991 to that in 1996?
Offer a very short reply. 1.51. What is the ratio of the Rent(as % of GDP) of Macao in 1991 to that in 1996?
Your response must be concise. 2.83. What is the ratio of the Rent(as % of GDP) in New Zealand in 1991 to that in 1996?
Provide a short and direct response. 1.29. What is the ratio of the Rent(as % of GDP) in Gabon in 1992 to that in 1993?
Keep it short and to the point. 0.6. What is the ratio of the Rent(as % of GDP) in Japan in 1992 to that in 1993?
Keep it short and to the point. 1.09. What is the ratio of the Rent(as % of GDP) in Macao in 1992 to that in 1993?
Give a very brief answer. 1.38. What is the ratio of the Rent(as % of GDP) of New Zealand in 1992 to that in 1993?
Provide a succinct answer. 0.94. What is the ratio of the Rent(as % of GDP) of Gabon in 1992 to that in 1994?
Ensure brevity in your answer.  0.5. What is the ratio of the Rent(as % of GDP) in Japan in 1992 to that in 1994?
Your answer should be very brief. 1.38. What is the ratio of the Rent(as % of GDP) in Macao in 1992 to that in 1994?
Offer a terse response. 1.38. What is the ratio of the Rent(as % of GDP) of New Zealand in 1992 to that in 1994?
Provide a succinct answer. 1.15. What is the ratio of the Rent(as % of GDP) of Gabon in 1992 to that in 1995?
Give a very brief answer. 0.48. What is the ratio of the Rent(as % of GDP) of Japan in 1992 to that in 1995?
Your answer should be very brief. 1.53. What is the ratio of the Rent(as % of GDP) in Macao in 1992 to that in 1995?
Provide a short and direct response. 1.25. What is the ratio of the Rent(as % of GDP) in New Zealand in 1992 to that in 1995?
Make the answer very short. 1.23. What is the ratio of the Rent(as % of GDP) in Gabon in 1992 to that in 1996?
Ensure brevity in your answer.  0.58. What is the ratio of the Rent(as % of GDP) of Japan in 1992 to that in 1996?
Your answer should be compact. 1.35. What is the ratio of the Rent(as % of GDP) of Macao in 1992 to that in 1996?
Your answer should be very brief. 1.55. What is the ratio of the Rent(as % of GDP) of New Zealand in 1992 to that in 1996?
Your answer should be compact. 1.39. What is the ratio of the Rent(as % of GDP) in Gabon in 1993 to that in 1994?
Keep it short and to the point. 0.84. What is the ratio of the Rent(as % of GDP) of Japan in 1993 to that in 1994?
Ensure brevity in your answer.  1.27. What is the ratio of the Rent(as % of GDP) in Macao in 1993 to that in 1994?
Offer a very short reply. 1. What is the ratio of the Rent(as % of GDP) of New Zealand in 1993 to that in 1994?
Offer a terse response. 1.22. What is the ratio of the Rent(as % of GDP) in Gabon in 1993 to that in 1995?
Offer a terse response. 0.8. What is the ratio of the Rent(as % of GDP) of Japan in 1993 to that in 1995?
Your answer should be compact. 1.41. What is the ratio of the Rent(as % of GDP) in Macao in 1993 to that in 1995?
Give a very brief answer. 0.91. What is the ratio of the Rent(as % of GDP) of New Zealand in 1993 to that in 1995?
Offer a very short reply. 1.3. What is the ratio of the Rent(as % of GDP) in Gabon in 1993 to that in 1996?
Offer a very short reply. 0.97. What is the ratio of the Rent(as % of GDP) of Japan in 1993 to that in 1996?
Offer a very short reply. 1.24. What is the ratio of the Rent(as % of GDP) of Macao in 1993 to that in 1996?
Make the answer very short. 1.12. What is the ratio of the Rent(as % of GDP) of New Zealand in 1993 to that in 1996?
Offer a very short reply. 1.47. What is the ratio of the Rent(as % of GDP) of Gabon in 1994 to that in 1995?
Your answer should be compact. 0.95. What is the ratio of the Rent(as % of GDP) of Japan in 1994 to that in 1995?
Provide a succinct answer. 1.11. What is the ratio of the Rent(as % of GDP) in Macao in 1994 to that in 1995?
Offer a terse response. 0.91. What is the ratio of the Rent(as % of GDP) of New Zealand in 1994 to that in 1995?
Offer a terse response. 1.07. What is the ratio of the Rent(as % of GDP) of Gabon in 1994 to that in 1996?
Provide a succinct answer. 1.16. What is the ratio of the Rent(as % of GDP) of Japan in 1994 to that in 1996?
Keep it short and to the point. 0.98. What is the ratio of the Rent(as % of GDP) in Macao in 1994 to that in 1996?
Offer a terse response. 1.12. What is the ratio of the Rent(as % of GDP) in New Zealand in 1994 to that in 1996?
Your response must be concise. 1.2. What is the ratio of the Rent(as % of GDP) in Gabon in 1995 to that in 1996?
Make the answer very short. 1.22. What is the ratio of the Rent(as % of GDP) of Japan in 1995 to that in 1996?
Keep it short and to the point. 0.88. What is the ratio of the Rent(as % of GDP) in Macao in 1995 to that in 1996?
Offer a very short reply. 1.23. What is the ratio of the Rent(as % of GDP) of New Zealand in 1995 to that in 1996?
Offer a terse response. 1.13. What is the difference between the highest and the second highest Rent(as % of GDP) in Gabon?
Your answer should be very brief. 0.22. What is the difference between the highest and the second highest Rent(as % of GDP) of Japan?
Provide a succinct answer. 0. What is the difference between the highest and the second highest Rent(as % of GDP) of Macao?
Your answer should be compact. 0. What is the difference between the highest and the second highest Rent(as % of GDP) in New Zealand?
Your answer should be compact. 0.06. What is the difference between the highest and the lowest Rent(as % of GDP) in Gabon?
Keep it short and to the point. 2.64. What is the difference between the highest and the lowest Rent(as % of GDP) of Japan?
Provide a short and direct response. 0.03. What is the difference between the highest and the lowest Rent(as % of GDP) of Macao?
Your response must be concise. 0.01. What is the difference between the highest and the lowest Rent(as % of GDP) of New Zealand?
Offer a very short reply. 0.34. 